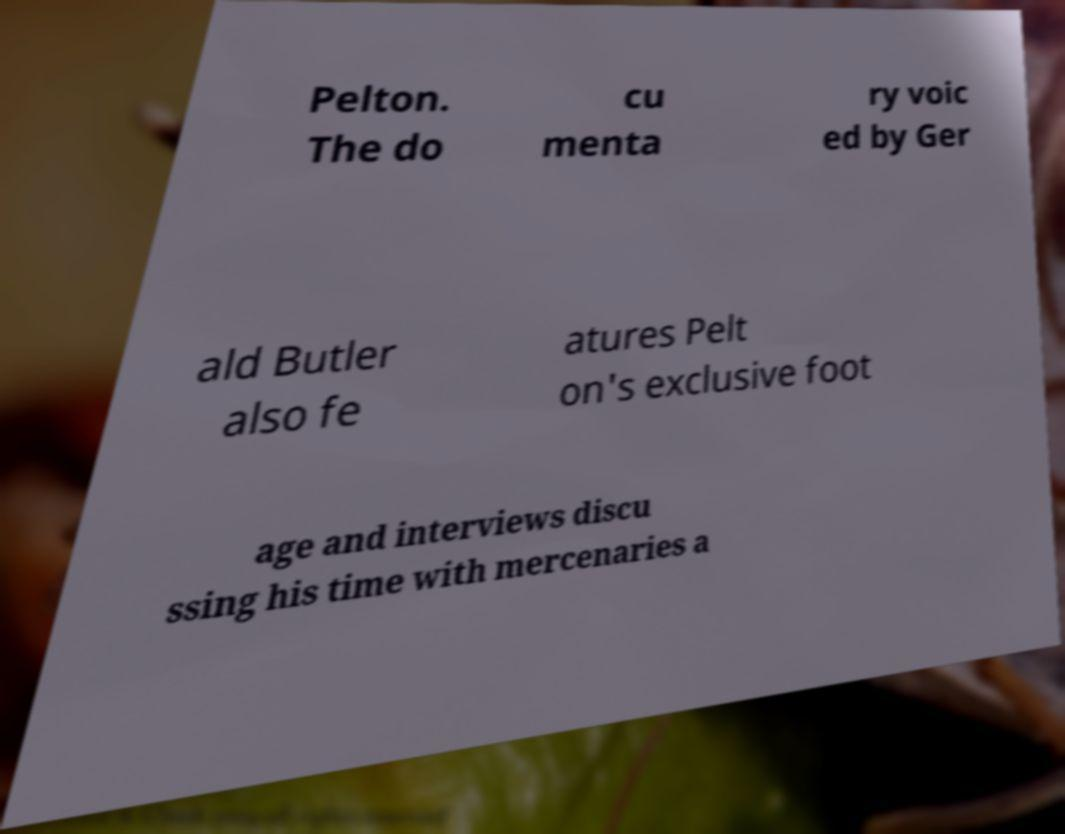For documentation purposes, I need the text within this image transcribed. Could you provide that? Pelton. The do cu menta ry voic ed by Ger ald Butler also fe atures Pelt on's exclusive foot age and interviews discu ssing his time with mercenaries a 